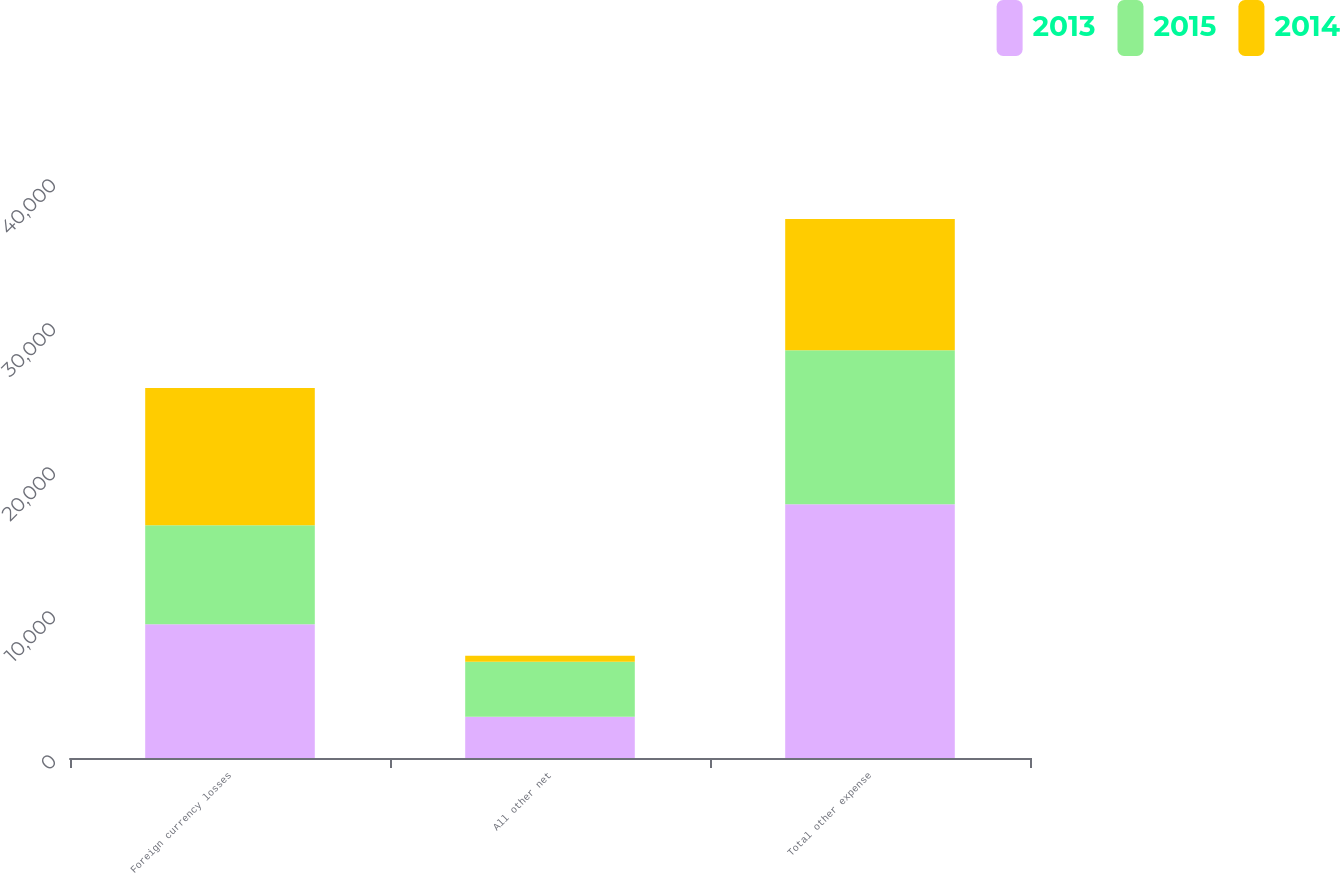<chart> <loc_0><loc_0><loc_500><loc_500><stacked_bar_chart><ecel><fcel>Foreign currency losses<fcel>All other net<fcel>Total other expense<nl><fcel>2013<fcel>9295<fcel>2856<fcel>17619<nl><fcel>2015<fcel>6869<fcel>3829<fcel>10698<nl><fcel>2014<fcel>9531<fcel>417<fcel>9114<nl></chart> 